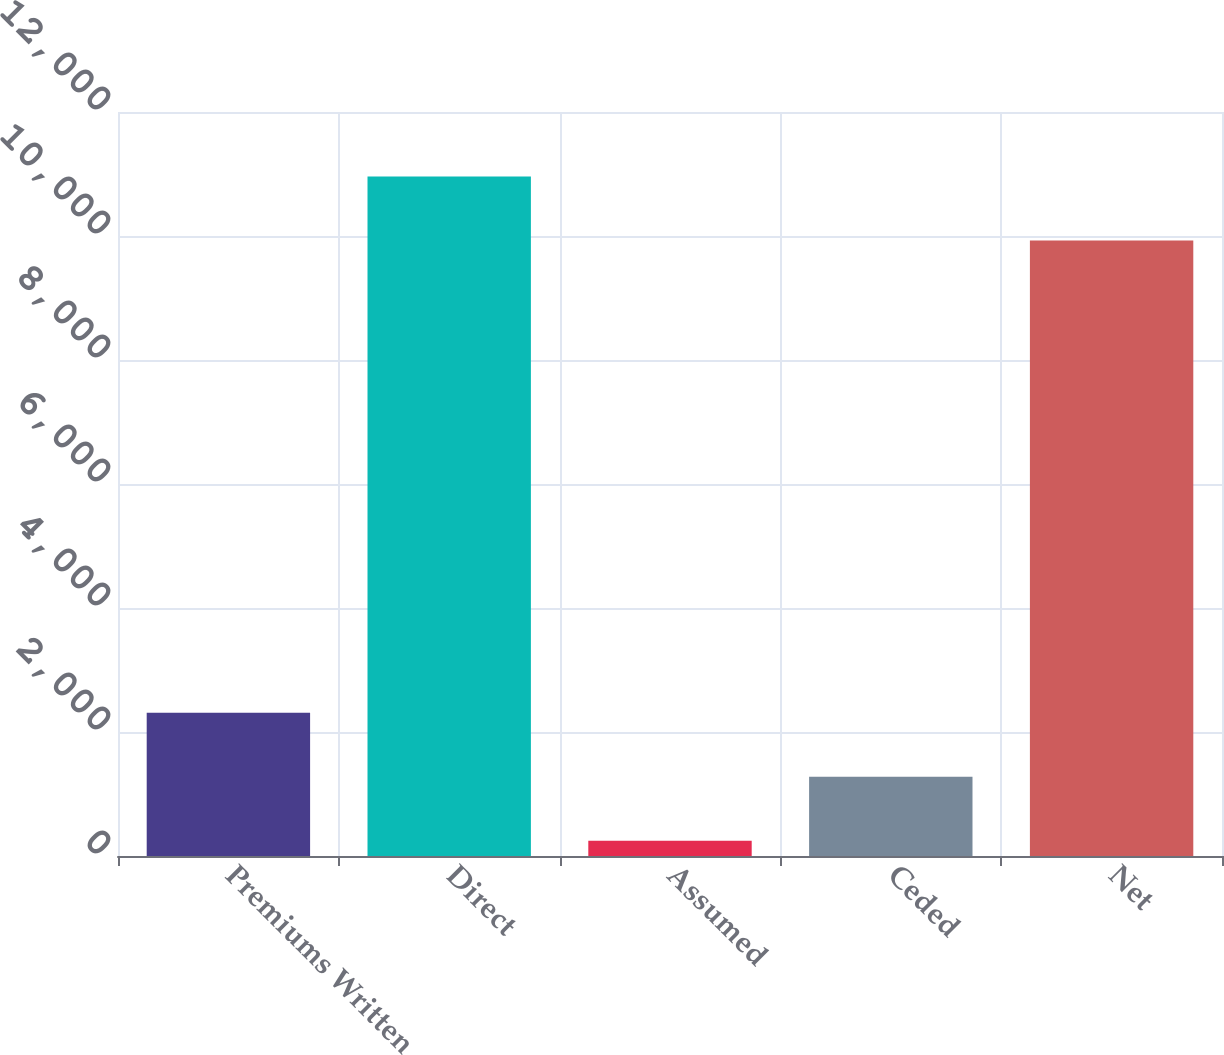Convert chart. <chart><loc_0><loc_0><loc_500><loc_500><bar_chart><fcel>Premiums Written<fcel>Direct<fcel>Assumed<fcel>Ceded<fcel>Net<nl><fcel>2310.4<fcel>10960.7<fcel>247<fcel>1278.7<fcel>9929<nl></chart> 